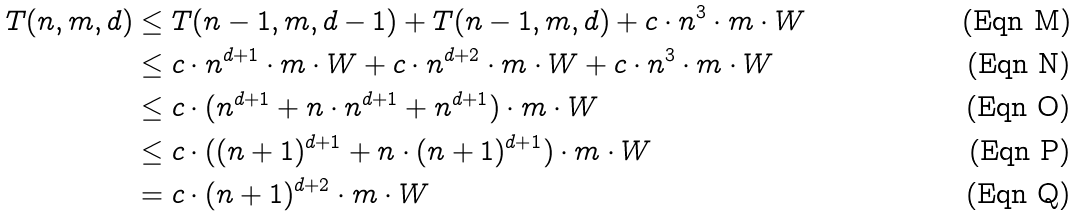<formula> <loc_0><loc_0><loc_500><loc_500>T ( n , m , d ) & \leq T ( n - 1 , m , d - 1 ) + T ( n - 1 , m , d ) + c \cdot n ^ { 3 } \cdot m \cdot W \\ & \leq c \cdot n ^ { d + 1 } \cdot m \cdot W + c \cdot n ^ { d + 2 } \cdot m \cdot W + c \cdot n ^ { 3 } \cdot m \cdot W \\ & \leq c \cdot ( n ^ { d + 1 } + n \cdot n ^ { d + 1 } + n ^ { d + 1 } ) \cdot m \cdot W \\ & \leq c \cdot ( ( n + 1 ) ^ { d + 1 } + n \cdot ( n + 1 ) ^ { d + 1 } ) \cdot m \cdot W \\ & = c \cdot ( n + 1 ) ^ { d + 2 } \cdot m \cdot W</formula> 